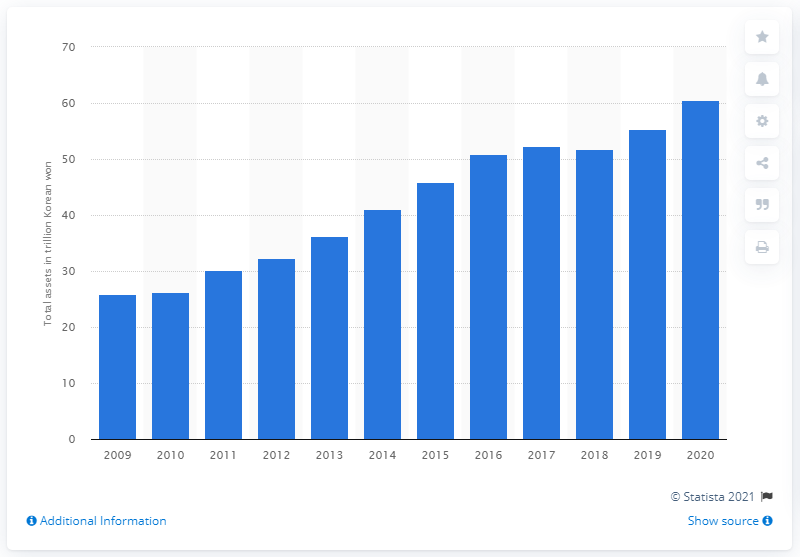Draw attention to some important aspects in this diagram. Kia's assets in the 2020 fiscal year were valued at 60.5 billion. 